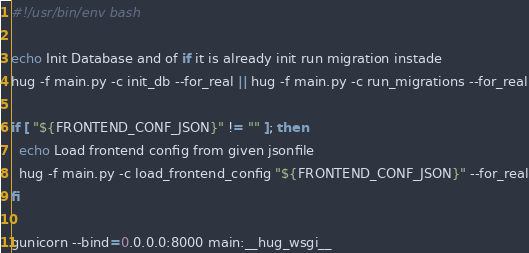Convert code to text. <code><loc_0><loc_0><loc_500><loc_500><_Bash_>#!/usr/bin/env bash

echo Init Database and of if it is already init run migration instade
hug -f main.py -c init_db --for_real || hug -f main.py -c run_migrations --for_real

if [ "${FRONTEND_CONF_JSON}" != "" ]; then
  echo Load frontend config from given jsonfile
  hug -f main.py -c load_frontend_config "${FRONTEND_CONF_JSON}" --for_real
fi

gunicorn --bind=0.0.0.0:8000 main:__hug_wsgi__
</code> 